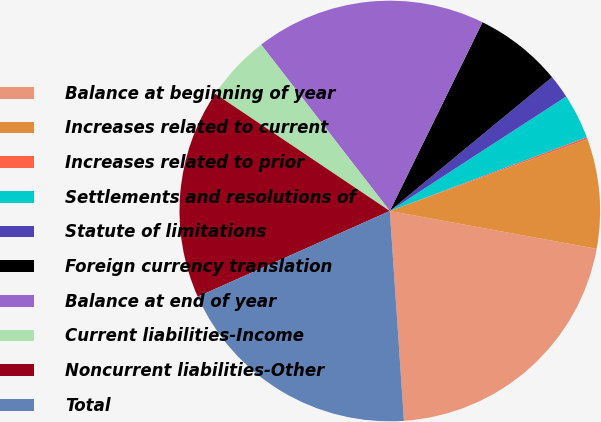Convert chart to OTSL. <chart><loc_0><loc_0><loc_500><loc_500><pie_chart><fcel>Balance at beginning of year<fcel>Increases related to current<fcel>Increases related to prior<fcel>Settlements and resolutions of<fcel>Statute of limitations<fcel>Foreign currency translation<fcel>Balance at end of year<fcel>Current liabilities-Income<fcel>Noncurrent liabilities-Other<fcel>Total<nl><fcel>21.05%<fcel>8.42%<fcel>0.16%<fcel>3.46%<fcel>1.81%<fcel>6.76%<fcel>17.74%<fcel>5.11%<fcel>16.09%<fcel>19.39%<nl></chart> 